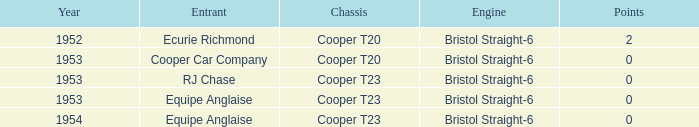In which years was the point total greater than 0? 1952.0. 